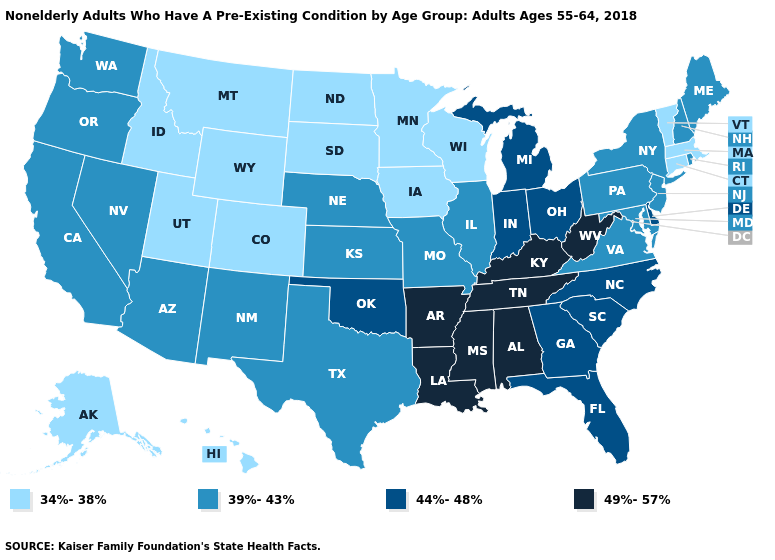What is the value of Massachusetts?
Quick response, please. 34%-38%. Name the states that have a value in the range 44%-48%?
Give a very brief answer. Delaware, Florida, Georgia, Indiana, Michigan, North Carolina, Ohio, Oklahoma, South Carolina. Name the states that have a value in the range 34%-38%?
Short answer required. Alaska, Colorado, Connecticut, Hawaii, Idaho, Iowa, Massachusetts, Minnesota, Montana, North Dakota, South Dakota, Utah, Vermont, Wisconsin, Wyoming. Name the states that have a value in the range 44%-48%?
Concise answer only. Delaware, Florida, Georgia, Indiana, Michigan, North Carolina, Ohio, Oklahoma, South Carolina. What is the value of Maryland?
Answer briefly. 39%-43%. What is the value of Pennsylvania?
Answer briefly. 39%-43%. Which states hav the highest value in the West?
Be succinct. Arizona, California, Nevada, New Mexico, Oregon, Washington. What is the value of Rhode Island?
Be succinct. 39%-43%. Does Florida have a lower value than Kentucky?
Keep it brief. Yes. Which states have the lowest value in the USA?
Keep it brief. Alaska, Colorado, Connecticut, Hawaii, Idaho, Iowa, Massachusetts, Minnesota, Montana, North Dakota, South Dakota, Utah, Vermont, Wisconsin, Wyoming. What is the value of Florida?
Write a very short answer. 44%-48%. Is the legend a continuous bar?
Concise answer only. No. What is the lowest value in the South?
Concise answer only. 39%-43%. What is the value of Texas?
Write a very short answer. 39%-43%. Which states have the highest value in the USA?
Concise answer only. Alabama, Arkansas, Kentucky, Louisiana, Mississippi, Tennessee, West Virginia. 